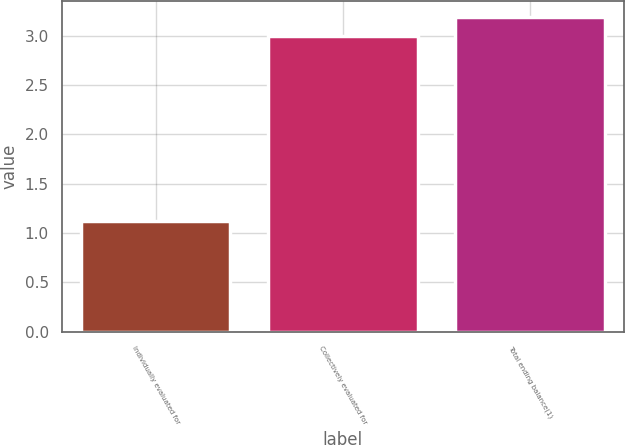Convert chart. <chart><loc_0><loc_0><loc_500><loc_500><bar_chart><fcel>Individually evaluated for<fcel>Collectively evaluated for<fcel>Total ending balance(1)<nl><fcel>1.12<fcel>3<fcel>3.19<nl></chart> 